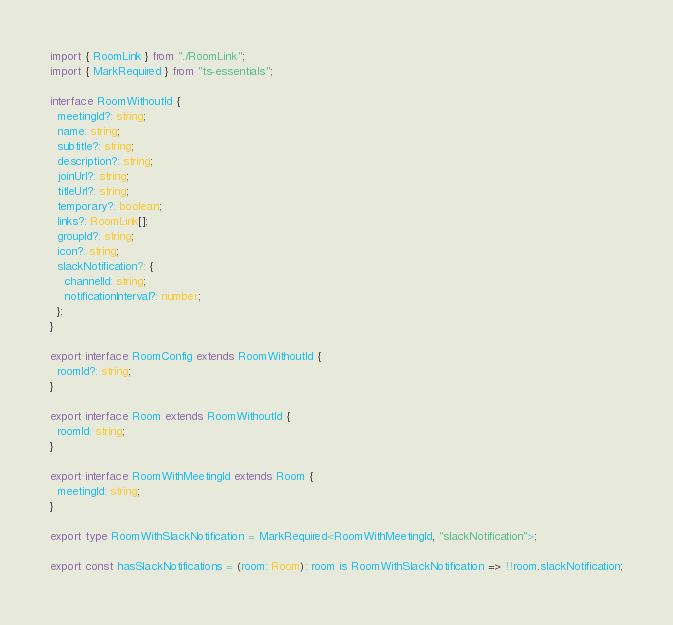<code> <loc_0><loc_0><loc_500><loc_500><_TypeScript_>import { RoomLink } from "./RoomLink";
import { MarkRequired } from "ts-essentials";

interface RoomWithoutId {
  meetingId?: string;
  name: string;
  subtitle?: string;
  description?: string;
  joinUrl?: string;
  titleUrl?: string;
  temporary?: boolean;
  links?: RoomLink[];
  groupId?: string;
  icon?: string;
  slackNotification?: {
    channelId: string;
    notificationInterval?: number;
  };
}

export interface RoomConfig extends RoomWithoutId {
  roomId?: string;
}

export interface Room extends RoomWithoutId {
  roomId: string;
}

export interface RoomWithMeetingId extends Room {
  meetingId: string;
}

export type RoomWithSlackNotification = MarkRequired<RoomWithMeetingId, "slackNotification">;

export const hasSlackNotifications = (room: Room): room is RoomWithSlackNotification => !!room.slackNotification;
</code> 